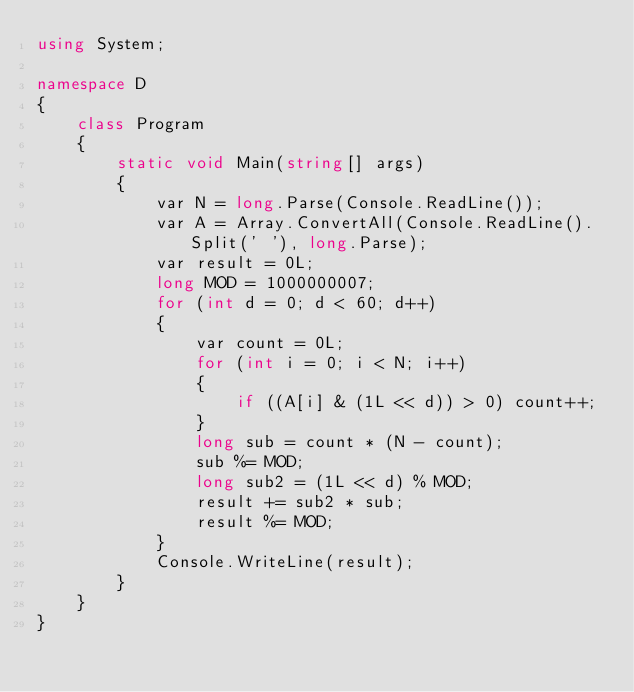<code> <loc_0><loc_0><loc_500><loc_500><_C#_>using System;

namespace D
{
    class Program
    {
        static void Main(string[] args)
        {
            var N = long.Parse(Console.ReadLine());
            var A = Array.ConvertAll(Console.ReadLine().Split(' '), long.Parse);
            var result = 0L;
            long MOD = 1000000007;
            for (int d = 0; d < 60; d++)
            {
                var count = 0L;
                for (int i = 0; i < N; i++)
                {
                    if ((A[i] & (1L << d)) > 0) count++;
                }
                long sub = count * (N - count);
                sub %= MOD;
                long sub2 = (1L << d) % MOD;
                result += sub2 * sub;
                result %= MOD;
            }
            Console.WriteLine(result);
        }
    }
}
</code> 